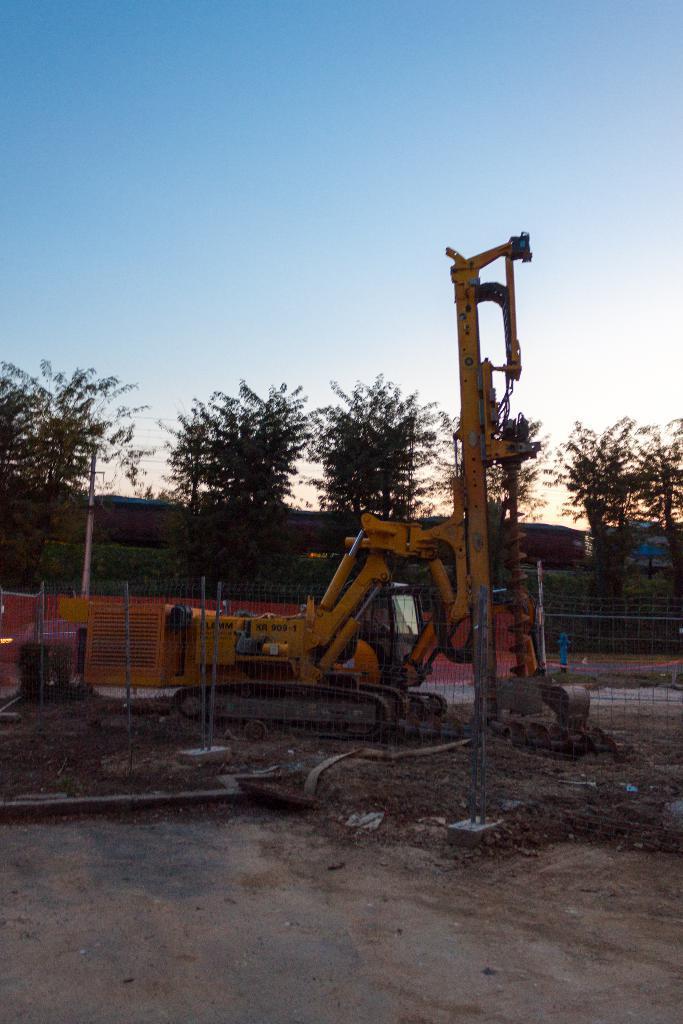Please provide a concise description of this image. In the picture we can see a mud surface on it, we can see a fencing and behind it, we can see mud removing equipment, vehicle and behind it, we can see the poles and trees and in the background we can see the sky. 